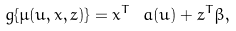Convert formula to latex. <formula><loc_0><loc_0><loc_500><loc_500>g \{ \mu ( u , x , z ) \} = x ^ { T } \ a ( u ) + z ^ { T } \beta ,</formula> 